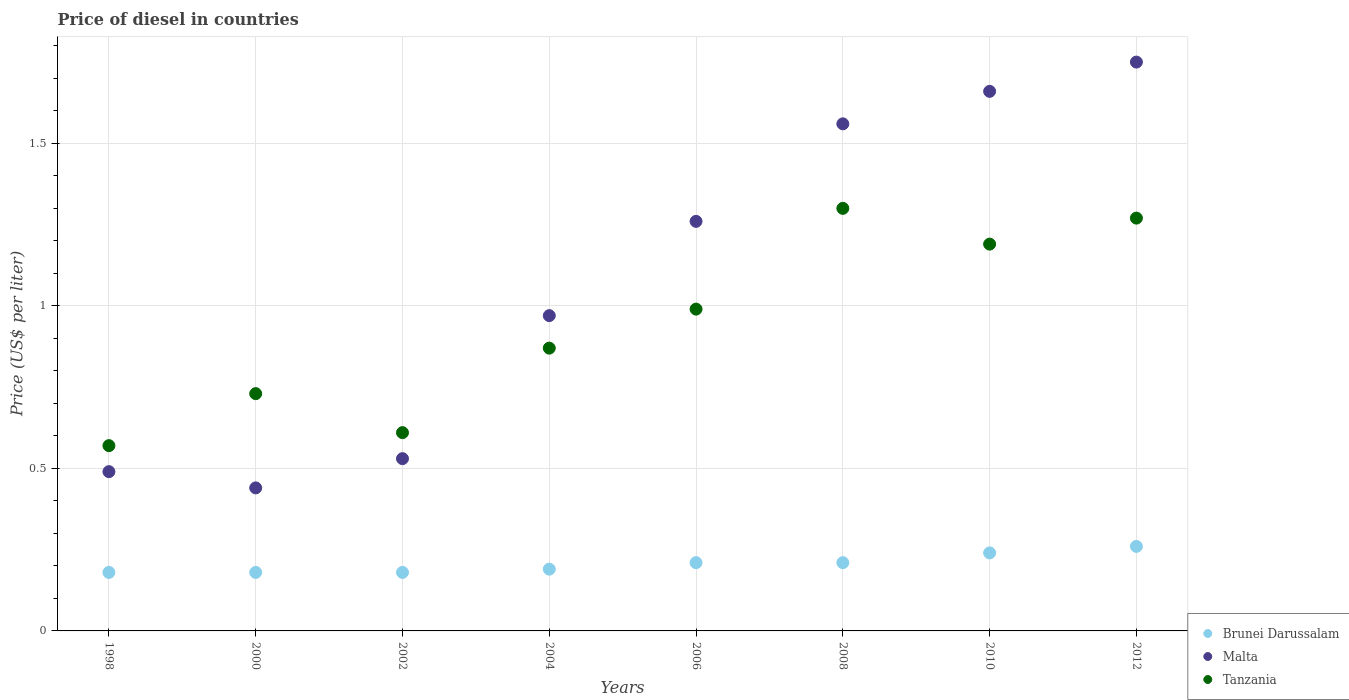Is the number of dotlines equal to the number of legend labels?
Provide a succinct answer. Yes. What is the price of diesel in Malta in 2004?
Offer a terse response. 0.97. Across all years, what is the minimum price of diesel in Brunei Darussalam?
Ensure brevity in your answer.  0.18. In which year was the price of diesel in Brunei Darussalam minimum?
Offer a very short reply. 1998. What is the total price of diesel in Brunei Darussalam in the graph?
Provide a short and direct response. 1.65. What is the difference between the price of diesel in Malta in 2002 and that in 2010?
Your answer should be very brief. -1.13. What is the difference between the price of diesel in Brunei Darussalam in 2004 and the price of diesel in Malta in 2008?
Give a very brief answer. -1.37. What is the average price of diesel in Malta per year?
Make the answer very short. 1.08. In the year 2006, what is the difference between the price of diesel in Malta and price of diesel in Brunei Darussalam?
Your response must be concise. 1.05. What is the ratio of the price of diesel in Malta in 2008 to that in 2012?
Offer a very short reply. 0.89. Is the difference between the price of diesel in Malta in 2008 and 2010 greater than the difference between the price of diesel in Brunei Darussalam in 2008 and 2010?
Offer a terse response. No. What is the difference between the highest and the second highest price of diesel in Brunei Darussalam?
Your response must be concise. 0.02. What is the difference between the highest and the lowest price of diesel in Brunei Darussalam?
Make the answer very short. 0.08. Is the sum of the price of diesel in Brunei Darussalam in 2002 and 2012 greater than the maximum price of diesel in Tanzania across all years?
Your response must be concise. No. Is it the case that in every year, the sum of the price of diesel in Brunei Darussalam and price of diesel in Tanzania  is greater than the price of diesel in Malta?
Ensure brevity in your answer.  No. How many dotlines are there?
Your response must be concise. 3. How many years are there in the graph?
Make the answer very short. 8. What is the difference between two consecutive major ticks on the Y-axis?
Your response must be concise. 0.5. Are the values on the major ticks of Y-axis written in scientific E-notation?
Make the answer very short. No. Does the graph contain grids?
Your answer should be very brief. Yes. Where does the legend appear in the graph?
Make the answer very short. Bottom right. What is the title of the graph?
Provide a succinct answer. Price of diesel in countries. Does "Guinea-Bissau" appear as one of the legend labels in the graph?
Keep it short and to the point. No. What is the label or title of the X-axis?
Offer a very short reply. Years. What is the label or title of the Y-axis?
Give a very brief answer. Price (US$ per liter). What is the Price (US$ per liter) in Brunei Darussalam in 1998?
Your answer should be very brief. 0.18. What is the Price (US$ per liter) in Malta in 1998?
Give a very brief answer. 0.49. What is the Price (US$ per liter) in Tanzania in 1998?
Keep it short and to the point. 0.57. What is the Price (US$ per liter) in Brunei Darussalam in 2000?
Ensure brevity in your answer.  0.18. What is the Price (US$ per liter) in Malta in 2000?
Make the answer very short. 0.44. What is the Price (US$ per liter) in Tanzania in 2000?
Your answer should be compact. 0.73. What is the Price (US$ per liter) of Brunei Darussalam in 2002?
Provide a short and direct response. 0.18. What is the Price (US$ per liter) of Malta in 2002?
Give a very brief answer. 0.53. What is the Price (US$ per liter) of Tanzania in 2002?
Offer a terse response. 0.61. What is the Price (US$ per liter) in Brunei Darussalam in 2004?
Give a very brief answer. 0.19. What is the Price (US$ per liter) of Tanzania in 2004?
Your answer should be compact. 0.87. What is the Price (US$ per liter) in Brunei Darussalam in 2006?
Give a very brief answer. 0.21. What is the Price (US$ per liter) in Malta in 2006?
Your response must be concise. 1.26. What is the Price (US$ per liter) in Brunei Darussalam in 2008?
Give a very brief answer. 0.21. What is the Price (US$ per liter) in Malta in 2008?
Give a very brief answer. 1.56. What is the Price (US$ per liter) of Brunei Darussalam in 2010?
Make the answer very short. 0.24. What is the Price (US$ per liter) in Malta in 2010?
Your answer should be very brief. 1.66. What is the Price (US$ per liter) in Tanzania in 2010?
Your answer should be very brief. 1.19. What is the Price (US$ per liter) in Brunei Darussalam in 2012?
Offer a very short reply. 0.26. What is the Price (US$ per liter) of Malta in 2012?
Offer a very short reply. 1.75. What is the Price (US$ per liter) of Tanzania in 2012?
Keep it short and to the point. 1.27. Across all years, what is the maximum Price (US$ per liter) of Brunei Darussalam?
Give a very brief answer. 0.26. Across all years, what is the maximum Price (US$ per liter) in Malta?
Offer a terse response. 1.75. Across all years, what is the maximum Price (US$ per liter) of Tanzania?
Provide a short and direct response. 1.3. Across all years, what is the minimum Price (US$ per liter) of Brunei Darussalam?
Keep it short and to the point. 0.18. Across all years, what is the minimum Price (US$ per liter) of Malta?
Your answer should be very brief. 0.44. Across all years, what is the minimum Price (US$ per liter) in Tanzania?
Give a very brief answer. 0.57. What is the total Price (US$ per liter) of Brunei Darussalam in the graph?
Your response must be concise. 1.65. What is the total Price (US$ per liter) of Malta in the graph?
Your response must be concise. 8.66. What is the total Price (US$ per liter) of Tanzania in the graph?
Provide a short and direct response. 7.53. What is the difference between the Price (US$ per liter) in Tanzania in 1998 and that in 2000?
Ensure brevity in your answer.  -0.16. What is the difference between the Price (US$ per liter) of Malta in 1998 and that in 2002?
Ensure brevity in your answer.  -0.04. What is the difference between the Price (US$ per liter) in Tanzania in 1998 and that in 2002?
Provide a short and direct response. -0.04. What is the difference between the Price (US$ per liter) in Brunei Darussalam in 1998 and that in 2004?
Give a very brief answer. -0.01. What is the difference between the Price (US$ per liter) in Malta in 1998 and that in 2004?
Keep it short and to the point. -0.48. What is the difference between the Price (US$ per liter) of Brunei Darussalam in 1998 and that in 2006?
Provide a succinct answer. -0.03. What is the difference between the Price (US$ per liter) in Malta in 1998 and that in 2006?
Your answer should be very brief. -0.77. What is the difference between the Price (US$ per liter) in Tanzania in 1998 and that in 2006?
Your answer should be very brief. -0.42. What is the difference between the Price (US$ per liter) of Brunei Darussalam in 1998 and that in 2008?
Keep it short and to the point. -0.03. What is the difference between the Price (US$ per liter) in Malta in 1998 and that in 2008?
Your answer should be compact. -1.07. What is the difference between the Price (US$ per liter) of Tanzania in 1998 and that in 2008?
Provide a short and direct response. -0.73. What is the difference between the Price (US$ per liter) of Brunei Darussalam in 1998 and that in 2010?
Provide a succinct answer. -0.06. What is the difference between the Price (US$ per liter) in Malta in 1998 and that in 2010?
Your response must be concise. -1.17. What is the difference between the Price (US$ per liter) of Tanzania in 1998 and that in 2010?
Make the answer very short. -0.62. What is the difference between the Price (US$ per liter) in Brunei Darussalam in 1998 and that in 2012?
Offer a very short reply. -0.08. What is the difference between the Price (US$ per liter) in Malta in 1998 and that in 2012?
Provide a short and direct response. -1.26. What is the difference between the Price (US$ per liter) in Tanzania in 1998 and that in 2012?
Your response must be concise. -0.7. What is the difference between the Price (US$ per liter) in Malta in 2000 and that in 2002?
Make the answer very short. -0.09. What is the difference between the Price (US$ per liter) of Tanzania in 2000 and that in 2002?
Your answer should be compact. 0.12. What is the difference between the Price (US$ per liter) in Brunei Darussalam in 2000 and that in 2004?
Keep it short and to the point. -0.01. What is the difference between the Price (US$ per liter) of Malta in 2000 and that in 2004?
Provide a short and direct response. -0.53. What is the difference between the Price (US$ per liter) in Tanzania in 2000 and that in 2004?
Make the answer very short. -0.14. What is the difference between the Price (US$ per liter) of Brunei Darussalam in 2000 and that in 2006?
Offer a terse response. -0.03. What is the difference between the Price (US$ per liter) of Malta in 2000 and that in 2006?
Provide a succinct answer. -0.82. What is the difference between the Price (US$ per liter) of Tanzania in 2000 and that in 2006?
Provide a short and direct response. -0.26. What is the difference between the Price (US$ per liter) of Brunei Darussalam in 2000 and that in 2008?
Provide a succinct answer. -0.03. What is the difference between the Price (US$ per liter) of Malta in 2000 and that in 2008?
Your response must be concise. -1.12. What is the difference between the Price (US$ per liter) of Tanzania in 2000 and that in 2008?
Offer a very short reply. -0.57. What is the difference between the Price (US$ per liter) in Brunei Darussalam in 2000 and that in 2010?
Make the answer very short. -0.06. What is the difference between the Price (US$ per liter) in Malta in 2000 and that in 2010?
Your answer should be very brief. -1.22. What is the difference between the Price (US$ per liter) of Tanzania in 2000 and that in 2010?
Provide a succinct answer. -0.46. What is the difference between the Price (US$ per liter) of Brunei Darussalam in 2000 and that in 2012?
Provide a succinct answer. -0.08. What is the difference between the Price (US$ per liter) of Malta in 2000 and that in 2012?
Your answer should be compact. -1.31. What is the difference between the Price (US$ per liter) of Tanzania in 2000 and that in 2012?
Your answer should be compact. -0.54. What is the difference between the Price (US$ per liter) in Brunei Darussalam in 2002 and that in 2004?
Your answer should be compact. -0.01. What is the difference between the Price (US$ per liter) of Malta in 2002 and that in 2004?
Your response must be concise. -0.44. What is the difference between the Price (US$ per liter) in Tanzania in 2002 and that in 2004?
Provide a succinct answer. -0.26. What is the difference between the Price (US$ per liter) in Brunei Darussalam in 2002 and that in 2006?
Offer a terse response. -0.03. What is the difference between the Price (US$ per liter) in Malta in 2002 and that in 2006?
Your answer should be compact. -0.73. What is the difference between the Price (US$ per liter) in Tanzania in 2002 and that in 2006?
Your answer should be very brief. -0.38. What is the difference between the Price (US$ per liter) in Brunei Darussalam in 2002 and that in 2008?
Provide a succinct answer. -0.03. What is the difference between the Price (US$ per liter) of Malta in 2002 and that in 2008?
Give a very brief answer. -1.03. What is the difference between the Price (US$ per liter) in Tanzania in 2002 and that in 2008?
Provide a succinct answer. -0.69. What is the difference between the Price (US$ per liter) in Brunei Darussalam in 2002 and that in 2010?
Provide a short and direct response. -0.06. What is the difference between the Price (US$ per liter) of Malta in 2002 and that in 2010?
Offer a terse response. -1.13. What is the difference between the Price (US$ per liter) of Tanzania in 2002 and that in 2010?
Ensure brevity in your answer.  -0.58. What is the difference between the Price (US$ per liter) in Brunei Darussalam in 2002 and that in 2012?
Make the answer very short. -0.08. What is the difference between the Price (US$ per liter) of Malta in 2002 and that in 2012?
Your answer should be compact. -1.22. What is the difference between the Price (US$ per liter) of Tanzania in 2002 and that in 2012?
Your answer should be very brief. -0.66. What is the difference between the Price (US$ per liter) of Brunei Darussalam in 2004 and that in 2006?
Provide a short and direct response. -0.02. What is the difference between the Price (US$ per liter) in Malta in 2004 and that in 2006?
Make the answer very short. -0.29. What is the difference between the Price (US$ per liter) of Tanzania in 2004 and that in 2006?
Ensure brevity in your answer.  -0.12. What is the difference between the Price (US$ per liter) of Brunei Darussalam in 2004 and that in 2008?
Offer a terse response. -0.02. What is the difference between the Price (US$ per liter) of Malta in 2004 and that in 2008?
Provide a succinct answer. -0.59. What is the difference between the Price (US$ per liter) of Tanzania in 2004 and that in 2008?
Your answer should be compact. -0.43. What is the difference between the Price (US$ per liter) of Malta in 2004 and that in 2010?
Your response must be concise. -0.69. What is the difference between the Price (US$ per liter) in Tanzania in 2004 and that in 2010?
Your answer should be very brief. -0.32. What is the difference between the Price (US$ per liter) in Brunei Darussalam in 2004 and that in 2012?
Give a very brief answer. -0.07. What is the difference between the Price (US$ per liter) in Malta in 2004 and that in 2012?
Provide a short and direct response. -0.78. What is the difference between the Price (US$ per liter) of Tanzania in 2006 and that in 2008?
Offer a very short reply. -0.31. What is the difference between the Price (US$ per liter) of Brunei Darussalam in 2006 and that in 2010?
Keep it short and to the point. -0.03. What is the difference between the Price (US$ per liter) in Malta in 2006 and that in 2012?
Your response must be concise. -0.49. What is the difference between the Price (US$ per liter) of Tanzania in 2006 and that in 2012?
Make the answer very short. -0.28. What is the difference between the Price (US$ per liter) of Brunei Darussalam in 2008 and that in 2010?
Give a very brief answer. -0.03. What is the difference between the Price (US$ per liter) of Tanzania in 2008 and that in 2010?
Offer a terse response. 0.11. What is the difference between the Price (US$ per liter) in Malta in 2008 and that in 2012?
Give a very brief answer. -0.19. What is the difference between the Price (US$ per liter) of Brunei Darussalam in 2010 and that in 2012?
Provide a short and direct response. -0.02. What is the difference between the Price (US$ per liter) of Malta in 2010 and that in 2012?
Provide a short and direct response. -0.09. What is the difference between the Price (US$ per liter) in Tanzania in 2010 and that in 2012?
Ensure brevity in your answer.  -0.08. What is the difference between the Price (US$ per liter) of Brunei Darussalam in 1998 and the Price (US$ per liter) of Malta in 2000?
Your answer should be very brief. -0.26. What is the difference between the Price (US$ per liter) of Brunei Darussalam in 1998 and the Price (US$ per liter) of Tanzania in 2000?
Keep it short and to the point. -0.55. What is the difference between the Price (US$ per liter) of Malta in 1998 and the Price (US$ per liter) of Tanzania in 2000?
Keep it short and to the point. -0.24. What is the difference between the Price (US$ per liter) of Brunei Darussalam in 1998 and the Price (US$ per liter) of Malta in 2002?
Keep it short and to the point. -0.35. What is the difference between the Price (US$ per liter) of Brunei Darussalam in 1998 and the Price (US$ per liter) of Tanzania in 2002?
Offer a terse response. -0.43. What is the difference between the Price (US$ per liter) in Malta in 1998 and the Price (US$ per liter) in Tanzania in 2002?
Keep it short and to the point. -0.12. What is the difference between the Price (US$ per liter) of Brunei Darussalam in 1998 and the Price (US$ per liter) of Malta in 2004?
Offer a terse response. -0.79. What is the difference between the Price (US$ per liter) of Brunei Darussalam in 1998 and the Price (US$ per liter) of Tanzania in 2004?
Offer a terse response. -0.69. What is the difference between the Price (US$ per liter) in Malta in 1998 and the Price (US$ per liter) in Tanzania in 2004?
Provide a short and direct response. -0.38. What is the difference between the Price (US$ per liter) of Brunei Darussalam in 1998 and the Price (US$ per liter) of Malta in 2006?
Ensure brevity in your answer.  -1.08. What is the difference between the Price (US$ per liter) in Brunei Darussalam in 1998 and the Price (US$ per liter) in Tanzania in 2006?
Your response must be concise. -0.81. What is the difference between the Price (US$ per liter) in Malta in 1998 and the Price (US$ per liter) in Tanzania in 2006?
Provide a succinct answer. -0.5. What is the difference between the Price (US$ per liter) in Brunei Darussalam in 1998 and the Price (US$ per liter) in Malta in 2008?
Your response must be concise. -1.38. What is the difference between the Price (US$ per liter) of Brunei Darussalam in 1998 and the Price (US$ per liter) of Tanzania in 2008?
Provide a succinct answer. -1.12. What is the difference between the Price (US$ per liter) in Malta in 1998 and the Price (US$ per liter) in Tanzania in 2008?
Provide a short and direct response. -0.81. What is the difference between the Price (US$ per liter) in Brunei Darussalam in 1998 and the Price (US$ per liter) in Malta in 2010?
Keep it short and to the point. -1.48. What is the difference between the Price (US$ per liter) of Brunei Darussalam in 1998 and the Price (US$ per liter) of Tanzania in 2010?
Make the answer very short. -1.01. What is the difference between the Price (US$ per liter) in Brunei Darussalam in 1998 and the Price (US$ per liter) in Malta in 2012?
Make the answer very short. -1.57. What is the difference between the Price (US$ per liter) in Brunei Darussalam in 1998 and the Price (US$ per liter) in Tanzania in 2012?
Provide a short and direct response. -1.09. What is the difference between the Price (US$ per liter) in Malta in 1998 and the Price (US$ per liter) in Tanzania in 2012?
Provide a succinct answer. -0.78. What is the difference between the Price (US$ per liter) in Brunei Darussalam in 2000 and the Price (US$ per liter) in Malta in 2002?
Provide a succinct answer. -0.35. What is the difference between the Price (US$ per liter) in Brunei Darussalam in 2000 and the Price (US$ per liter) in Tanzania in 2002?
Your answer should be very brief. -0.43. What is the difference between the Price (US$ per liter) of Malta in 2000 and the Price (US$ per liter) of Tanzania in 2002?
Provide a short and direct response. -0.17. What is the difference between the Price (US$ per liter) in Brunei Darussalam in 2000 and the Price (US$ per liter) in Malta in 2004?
Make the answer very short. -0.79. What is the difference between the Price (US$ per liter) in Brunei Darussalam in 2000 and the Price (US$ per liter) in Tanzania in 2004?
Offer a terse response. -0.69. What is the difference between the Price (US$ per liter) of Malta in 2000 and the Price (US$ per liter) of Tanzania in 2004?
Give a very brief answer. -0.43. What is the difference between the Price (US$ per liter) in Brunei Darussalam in 2000 and the Price (US$ per liter) in Malta in 2006?
Your answer should be very brief. -1.08. What is the difference between the Price (US$ per liter) in Brunei Darussalam in 2000 and the Price (US$ per liter) in Tanzania in 2006?
Provide a short and direct response. -0.81. What is the difference between the Price (US$ per liter) of Malta in 2000 and the Price (US$ per liter) of Tanzania in 2006?
Provide a succinct answer. -0.55. What is the difference between the Price (US$ per liter) in Brunei Darussalam in 2000 and the Price (US$ per liter) in Malta in 2008?
Give a very brief answer. -1.38. What is the difference between the Price (US$ per liter) in Brunei Darussalam in 2000 and the Price (US$ per liter) in Tanzania in 2008?
Your answer should be compact. -1.12. What is the difference between the Price (US$ per liter) of Malta in 2000 and the Price (US$ per liter) of Tanzania in 2008?
Provide a succinct answer. -0.86. What is the difference between the Price (US$ per liter) in Brunei Darussalam in 2000 and the Price (US$ per liter) in Malta in 2010?
Your answer should be very brief. -1.48. What is the difference between the Price (US$ per liter) of Brunei Darussalam in 2000 and the Price (US$ per liter) of Tanzania in 2010?
Provide a short and direct response. -1.01. What is the difference between the Price (US$ per liter) of Malta in 2000 and the Price (US$ per liter) of Tanzania in 2010?
Provide a short and direct response. -0.75. What is the difference between the Price (US$ per liter) of Brunei Darussalam in 2000 and the Price (US$ per liter) of Malta in 2012?
Offer a very short reply. -1.57. What is the difference between the Price (US$ per liter) in Brunei Darussalam in 2000 and the Price (US$ per liter) in Tanzania in 2012?
Provide a short and direct response. -1.09. What is the difference between the Price (US$ per liter) in Malta in 2000 and the Price (US$ per liter) in Tanzania in 2012?
Provide a succinct answer. -0.83. What is the difference between the Price (US$ per liter) in Brunei Darussalam in 2002 and the Price (US$ per liter) in Malta in 2004?
Ensure brevity in your answer.  -0.79. What is the difference between the Price (US$ per liter) of Brunei Darussalam in 2002 and the Price (US$ per liter) of Tanzania in 2004?
Offer a very short reply. -0.69. What is the difference between the Price (US$ per liter) in Malta in 2002 and the Price (US$ per liter) in Tanzania in 2004?
Give a very brief answer. -0.34. What is the difference between the Price (US$ per liter) in Brunei Darussalam in 2002 and the Price (US$ per liter) in Malta in 2006?
Ensure brevity in your answer.  -1.08. What is the difference between the Price (US$ per liter) of Brunei Darussalam in 2002 and the Price (US$ per liter) of Tanzania in 2006?
Your response must be concise. -0.81. What is the difference between the Price (US$ per liter) of Malta in 2002 and the Price (US$ per liter) of Tanzania in 2006?
Your answer should be compact. -0.46. What is the difference between the Price (US$ per liter) in Brunei Darussalam in 2002 and the Price (US$ per liter) in Malta in 2008?
Ensure brevity in your answer.  -1.38. What is the difference between the Price (US$ per liter) of Brunei Darussalam in 2002 and the Price (US$ per liter) of Tanzania in 2008?
Offer a very short reply. -1.12. What is the difference between the Price (US$ per liter) in Malta in 2002 and the Price (US$ per liter) in Tanzania in 2008?
Ensure brevity in your answer.  -0.77. What is the difference between the Price (US$ per liter) of Brunei Darussalam in 2002 and the Price (US$ per liter) of Malta in 2010?
Make the answer very short. -1.48. What is the difference between the Price (US$ per liter) in Brunei Darussalam in 2002 and the Price (US$ per liter) in Tanzania in 2010?
Make the answer very short. -1.01. What is the difference between the Price (US$ per liter) in Malta in 2002 and the Price (US$ per liter) in Tanzania in 2010?
Ensure brevity in your answer.  -0.66. What is the difference between the Price (US$ per liter) of Brunei Darussalam in 2002 and the Price (US$ per liter) of Malta in 2012?
Make the answer very short. -1.57. What is the difference between the Price (US$ per liter) of Brunei Darussalam in 2002 and the Price (US$ per liter) of Tanzania in 2012?
Offer a terse response. -1.09. What is the difference between the Price (US$ per liter) of Malta in 2002 and the Price (US$ per liter) of Tanzania in 2012?
Provide a short and direct response. -0.74. What is the difference between the Price (US$ per liter) of Brunei Darussalam in 2004 and the Price (US$ per liter) of Malta in 2006?
Your response must be concise. -1.07. What is the difference between the Price (US$ per liter) in Malta in 2004 and the Price (US$ per liter) in Tanzania in 2006?
Offer a terse response. -0.02. What is the difference between the Price (US$ per liter) in Brunei Darussalam in 2004 and the Price (US$ per liter) in Malta in 2008?
Your answer should be compact. -1.37. What is the difference between the Price (US$ per liter) in Brunei Darussalam in 2004 and the Price (US$ per liter) in Tanzania in 2008?
Your answer should be very brief. -1.11. What is the difference between the Price (US$ per liter) in Malta in 2004 and the Price (US$ per liter) in Tanzania in 2008?
Keep it short and to the point. -0.33. What is the difference between the Price (US$ per liter) of Brunei Darussalam in 2004 and the Price (US$ per liter) of Malta in 2010?
Make the answer very short. -1.47. What is the difference between the Price (US$ per liter) of Brunei Darussalam in 2004 and the Price (US$ per liter) of Tanzania in 2010?
Your response must be concise. -1. What is the difference between the Price (US$ per liter) in Malta in 2004 and the Price (US$ per liter) in Tanzania in 2010?
Offer a very short reply. -0.22. What is the difference between the Price (US$ per liter) in Brunei Darussalam in 2004 and the Price (US$ per liter) in Malta in 2012?
Offer a very short reply. -1.56. What is the difference between the Price (US$ per liter) of Brunei Darussalam in 2004 and the Price (US$ per liter) of Tanzania in 2012?
Keep it short and to the point. -1.08. What is the difference between the Price (US$ per liter) in Brunei Darussalam in 2006 and the Price (US$ per liter) in Malta in 2008?
Provide a short and direct response. -1.35. What is the difference between the Price (US$ per liter) in Brunei Darussalam in 2006 and the Price (US$ per liter) in Tanzania in 2008?
Keep it short and to the point. -1.09. What is the difference between the Price (US$ per liter) of Malta in 2006 and the Price (US$ per liter) of Tanzania in 2008?
Provide a succinct answer. -0.04. What is the difference between the Price (US$ per liter) of Brunei Darussalam in 2006 and the Price (US$ per liter) of Malta in 2010?
Provide a succinct answer. -1.45. What is the difference between the Price (US$ per liter) in Brunei Darussalam in 2006 and the Price (US$ per liter) in Tanzania in 2010?
Offer a terse response. -0.98. What is the difference between the Price (US$ per liter) in Malta in 2006 and the Price (US$ per liter) in Tanzania in 2010?
Your response must be concise. 0.07. What is the difference between the Price (US$ per liter) in Brunei Darussalam in 2006 and the Price (US$ per liter) in Malta in 2012?
Offer a terse response. -1.54. What is the difference between the Price (US$ per liter) of Brunei Darussalam in 2006 and the Price (US$ per liter) of Tanzania in 2012?
Give a very brief answer. -1.06. What is the difference between the Price (US$ per liter) of Malta in 2006 and the Price (US$ per liter) of Tanzania in 2012?
Provide a short and direct response. -0.01. What is the difference between the Price (US$ per liter) of Brunei Darussalam in 2008 and the Price (US$ per liter) of Malta in 2010?
Keep it short and to the point. -1.45. What is the difference between the Price (US$ per liter) in Brunei Darussalam in 2008 and the Price (US$ per liter) in Tanzania in 2010?
Offer a very short reply. -0.98. What is the difference between the Price (US$ per liter) of Malta in 2008 and the Price (US$ per liter) of Tanzania in 2010?
Provide a short and direct response. 0.37. What is the difference between the Price (US$ per liter) in Brunei Darussalam in 2008 and the Price (US$ per liter) in Malta in 2012?
Ensure brevity in your answer.  -1.54. What is the difference between the Price (US$ per liter) of Brunei Darussalam in 2008 and the Price (US$ per liter) of Tanzania in 2012?
Offer a terse response. -1.06. What is the difference between the Price (US$ per liter) in Malta in 2008 and the Price (US$ per liter) in Tanzania in 2012?
Your answer should be compact. 0.29. What is the difference between the Price (US$ per liter) of Brunei Darussalam in 2010 and the Price (US$ per liter) of Malta in 2012?
Offer a terse response. -1.51. What is the difference between the Price (US$ per liter) of Brunei Darussalam in 2010 and the Price (US$ per liter) of Tanzania in 2012?
Offer a very short reply. -1.03. What is the difference between the Price (US$ per liter) of Malta in 2010 and the Price (US$ per liter) of Tanzania in 2012?
Provide a short and direct response. 0.39. What is the average Price (US$ per liter) of Brunei Darussalam per year?
Keep it short and to the point. 0.21. What is the average Price (US$ per liter) in Malta per year?
Offer a very short reply. 1.08. In the year 1998, what is the difference between the Price (US$ per liter) in Brunei Darussalam and Price (US$ per liter) in Malta?
Your answer should be compact. -0.31. In the year 1998, what is the difference between the Price (US$ per liter) of Brunei Darussalam and Price (US$ per liter) of Tanzania?
Your response must be concise. -0.39. In the year 1998, what is the difference between the Price (US$ per liter) of Malta and Price (US$ per liter) of Tanzania?
Keep it short and to the point. -0.08. In the year 2000, what is the difference between the Price (US$ per liter) of Brunei Darussalam and Price (US$ per liter) of Malta?
Provide a succinct answer. -0.26. In the year 2000, what is the difference between the Price (US$ per liter) of Brunei Darussalam and Price (US$ per liter) of Tanzania?
Keep it short and to the point. -0.55. In the year 2000, what is the difference between the Price (US$ per liter) of Malta and Price (US$ per liter) of Tanzania?
Offer a very short reply. -0.29. In the year 2002, what is the difference between the Price (US$ per liter) of Brunei Darussalam and Price (US$ per liter) of Malta?
Give a very brief answer. -0.35. In the year 2002, what is the difference between the Price (US$ per liter) in Brunei Darussalam and Price (US$ per liter) in Tanzania?
Offer a terse response. -0.43. In the year 2002, what is the difference between the Price (US$ per liter) of Malta and Price (US$ per liter) of Tanzania?
Offer a terse response. -0.08. In the year 2004, what is the difference between the Price (US$ per liter) of Brunei Darussalam and Price (US$ per liter) of Malta?
Keep it short and to the point. -0.78. In the year 2004, what is the difference between the Price (US$ per liter) in Brunei Darussalam and Price (US$ per liter) in Tanzania?
Offer a very short reply. -0.68. In the year 2006, what is the difference between the Price (US$ per liter) in Brunei Darussalam and Price (US$ per liter) in Malta?
Your response must be concise. -1.05. In the year 2006, what is the difference between the Price (US$ per liter) in Brunei Darussalam and Price (US$ per liter) in Tanzania?
Your answer should be very brief. -0.78. In the year 2006, what is the difference between the Price (US$ per liter) in Malta and Price (US$ per liter) in Tanzania?
Give a very brief answer. 0.27. In the year 2008, what is the difference between the Price (US$ per liter) of Brunei Darussalam and Price (US$ per liter) of Malta?
Give a very brief answer. -1.35. In the year 2008, what is the difference between the Price (US$ per liter) in Brunei Darussalam and Price (US$ per liter) in Tanzania?
Offer a very short reply. -1.09. In the year 2008, what is the difference between the Price (US$ per liter) in Malta and Price (US$ per liter) in Tanzania?
Offer a terse response. 0.26. In the year 2010, what is the difference between the Price (US$ per liter) of Brunei Darussalam and Price (US$ per liter) of Malta?
Offer a very short reply. -1.42. In the year 2010, what is the difference between the Price (US$ per liter) in Brunei Darussalam and Price (US$ per liter) in Tanzania?
Your response must be concise. -0.95. In the year 2010, what is the difference between the Price (US$ per liter) in Malta and Price (US$ per liter) in Tanzania?
Offer a very short reply. 0.47. In the year 2012, what is the difference between the Price (US$ per liter) in Brunei Darussalam and Price (US$ per liter) in Malta?
Offer a very short reply. -1.49. In the year 2012, what is the difference between the Price (US$ per liter) of Brunei Darussalam and Price (US$ per liter) of Tanzania?
Your response must be concise. -1.01. In the year 2012, what is the difference between the Price (US$ per liter) in Malta and Price (US$ per liter) in Tanzania?
Provide a succinct answer. 0.48. What is the ratio of the Price (US$ per liter) of Brunei Darussalam in 1998 to that in 2000?
Give a very brief answer. 1. What is the ratio of the Price (US$ per liter) in Malta in 1998 to that in 2000?
Your response must be concise. 1.11. What is the ratio of the Price (US$ per liter) in Tanzania in 1998 to that in 2000?
Keep it short and to the point. 0.78. What is the ratio of the Price (US$ per liter) in Malta in 1998 to that in 2002?
Offer a terse response. 0.92. What is the ratio of the Price (US$ per liter) of Tanzania in 1998 to that in 2002?
Provide a succinct answer. 0.93. What is the ratio of the Price (US$ per liter) in Malta in 1998 to that in 2004?
Make the answer very short. 0.51. What is the ratio of the Price (US$ per liter) in Tanzania in 1998 to that in 2004?
Keep it short and to the point. 0.66. What is the ratio of the Price (US$ per liter) in Brunei Darussalam in 1998 to that in 2006?
Offer a very short reply. 0.86. What is the ratio of the Price (US$ per liter) of Malta in 1998 to that in 2006?
Offer a very short reply. 0.39. What is the ratio of the Price (US$ per liter) of Tanzania in 1998 to that in 2006?
Offer a terse response. 0.58. What is the ratio of the Price (US$ per liter) of Malta in 1998 to that in 2008?
Give a very brief answer. 0.31. What is the ratio of the Price (US$ per liter) in Tanzania in 1998 to that in 2008?
Offer a very short reply. 0.44. What is the ratio of the Price (US$ per liter) in Malta in 1998 to that in 2010?
Make the answer very short. 0.3. What is the ratio of the Price (US$ per liter) in Tanzania in 1998 to that in 2010?
Offer a terse response. 0.48. What is the ratio of the Price (US$ per liter) of Brunei Darussalam in 1998 to that in 2012?
Make the answer very short. 0.69. What is the ratio of the Price (US$ per liter) in Malta in 1998 to that in 2012?
Make the answer very short. 0.28. What is the ratio of the Price (US$ per liter) in Tanzania in 1998 to that in 2012?
Your answer should be compact. 0.45. What is the ratio of the Price (US$ per liter) in Malta in 2000 to that in 2002?
Your answer should be very brief. 0.83. What is the ratio of the Price (US$ per liter) of Tanzania in 2000 to that in 2002?
Provide a succinct answer. 1.2. What is the ratio of the Price (US$ per liter) of Brunei Darussalam in 2000 to that in 2004?
Your answer should be compact. 0.95. What is the ratio of the Price (US$ per liter) of Malta in 2000 to that in 2004?
Provide a short and direct response. 0.45. What is the ratio of the Price (US$ per liter) of Tanzania in 2000 to that in 2004?
Ensure brevity in your answer.  0.84. What is the ratio of the Price (US$ per liter) in Malta in 2000 to that in 2006?
Your answer should be compact. 0.35. What is the ratio of the Price (US$ per liter) of Tanzania in 2000 to that in 2006?
Offer a terse response. 0.74. What is the ratio of the Price (US$ per liter) in Brunei Darussalam in 2000 to that in 2008?
Your response must be concise. 0.86. What is the ratio of the Price (US$ per liter) in Malta in 2000 to that in 2008?
Make the answer very short. 0.28. What is the ratio of the Price (US$ per liter) of Tanzania in 2000 to that in 2008?
Offer a very short reply. 0.56. What is the ratio of the Price (US$ per liter) of Brunei Darussalam in 2000 to that in 2010?
Your response must be concise. 0.75. What is the ratio of the Price (US$ per liter) of Malta in 2000 to that in 2010?
Give a very brief answer. 0.27. What is the ratio of the Price (US$ per liter) of Tanzania in 2000 to that in 2010?
Your response must be concise. 0.61. What is the ratio of the Price (US$ per liter) in Brunei Darussalam in 2000 to that in 2012?
Your answer should be very brief. 0.69. What is the ratio of the Price (US$ per liter) in Malta in 2000 to that in 2012?
Your answer should be very brief. 0.25. What is the ratio of the Price (US$ per liter) in Tanzania in 2000 to that in 2012?
Provide a short and direct response. 0.57. What is the ratio of the Price (US$ per liter) of Brunei Darussalam in 2002 to that in 2004?
Make the answer very short. 0.95. What is the ratio of the Price (US$ per liter) in Malta in 2002 to that in 2004?
Make the answer very short. 0.55. What is the ratio of the Price (US$ per liter) in Tanzania in 2002 to that in 2004?
Make the answer very short. 0.7. What is the ratio of the Price (US$ per liter) of Malta in 2002 to that in 2006?
Your response must be concise. 0.42. What is the ratio of the Price (US$ per liter) of Tanzania in 2002 to that in 2006?
Offer a terse response. 0.62. What is the ratio of the Price (US$ per liter) of Malta in 2002 to that in 2008?
Keep it short and to the point. 0.34. What is the ratio of the Price (US$ per liter) in Tanzania in 2002 to that in 2008?
Make the answer very short. 0.47. What is the ratio of the Price (US$ per liter) in Brunei Darussalam in 2002 to that in 2010?
Your answer should be compact. 0.75. What is the ratio of the Price (US$ per liter) in Malta in 2002 to that in 2010?
Offer a terse response. 0.32. What is the ratio of the Price (US$ per liter) of Tanzania in 2002 to that in 2010?
Give a very brief answer. 0.51. What is the ratio of the Price (US$ per liter) of Brunei Darussalam in 2002 to that in 2012?
Keep it short and to the point. 0.69. What is the ratio of the Price (US$ per liter) of Malta in 2002 to that in 2012?
Offer a very short reply. 0.3. What is the ratio of the Price (US$ per liter) of Tanzania in 2002 to that in 2012?
Your answer should be very brief. 0.48. What is the ratio of the Price (US$ per liter) in Brunei Darussalam in 2004 to that in 2006?
Your answer should be very brief. 0.9. What is the ratio of the Price (US$ per liter) in Malta in 2004 to that in 2006?
Make the answer very short. 0.77. What is the ratio of the Price (US$ per liter) of Tanzania in 2004 to that in 2006?
Give a very brief answer. 0.88. What is the ratio of the Price (US$ per liter) of Brunei Darussalam in 2004 to that in 2008?
Your response must be concise. 0.9. What is the ratio of the Price (US$ per liter) in Malta in 2004 to that in 2008?
Your answer should be compact. 0.62. What is the ratio of the Price (US$ per liter) in Tanzania in 2004 to that in 2008?
Give a very brief answer. 0.67. What is the ratio of the Price (US$ per liter) in Brunei Darussalam in 2004 to that in 2010?
Your answer should be very brief. 0.79. What is the ratio of the Price (US$ per liter) of Malta in 2004 to that in 2010?
Ensure brevity in your answer.  0.58. What is the ratio of the Price (US$ per liter) in Tanzania in 2004 to that in 2010?
Make the answer very short. 0.73. What is the ratio of the Price (US$ per liter) in Brunei Darussalam in 2004 to that in 2012?
Give a very brief answer. 0.73. What is the ratio of the Price (US$ per liter) in Malta in 2004 to that in 2012?
Offer a very short reply. 0.55. What is the ratio of the Price (US$ per liter) of Tanzania in 2004 to that in 2012?
Offer a terse response. 0.69. What is the ratio of the Price (US$ per liter) of Malta in 2006 to that in 2008?
Offer a very short reply. 0.81. What is the ratio of the Price (US$ per liter) of Tanzania in 2006 to that in 2008?
Offer a terse response. 0.76. What is the ratio of the Price (US$ per liter) of Malta in 2006 to that in 2010?
Provide a short and direct response. 0.76. What is the ratio of the Price (US$ per liter) in Tanzania in 2006 to that in 2010?
Give a very brief answer. 0.83. What is the ratio of the Price (US$ per liter) of Brunei Darussalam in 2006 to that in 2012?
Give a very brief answer. 0.81. What is the ratio of the Price (US$ per liter) in Malta in 2006 to that in 2012?
Offer a terse response. 0.72. What is the ratio of the Price (US$ per liter) of Tanzania in 2006 to that in 2012?
Make the answer very short. 0.78. What is the ratio of the Price (US$ per liter) in Malta in 2008 to that in 2010?
Your answer should be compact. 0.94. What is the ratio of the Price (US$ per liter) of Tanzania in 2008 to that in 2010?
Ensure brevity in your answer.  1.09. What is the ratio of the Price (US$ per liter) in Brunei Darussalam in 2008 to that in 2012?
Offer a very short reply. 0.81. What is the ratio of the Price (US$ per liter) of Malta in 2008 to that in 2012?
Provide a succinct answer. 0.89. What is the ratio of the Price (US$ per liter) in Tanzania in 2008 to that in 2012?
Make the answer very short. 1.02. What is the ratio of the Price (US$ per liter) of Malta in 2010 to that in 2012?
Your answer should be very brief. 0.95. What is the ratio of the Price (US$ per liter) of Tanzania in 2010 to that in 2012?
Offer a very short reply. 0.94. What is the difference between the highest and the second highest Price (US$ per liter) in Brunei Darussalam?
Your answer should be very brief. 0.02. What is the difference between the highest and the second highest Price (US$ per liter) in Malta?
Your answer should be compact. 0.09. What is the difference between the highest and the second highest Price (US$ per liter) of Tanzania?
Provide a succinct answer. 0.03. What is the difference between the highest and the lowest Price (US$ per liter) of Malta?
Your answer should be very brief. 1.31. What is the difference between the highest and the lowest Price (US$ per liter) of Tanzania?
Make the answer very short. 0.73. 